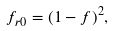<formula> <loc_0><loc_0><loc_500><loc_500>f _ { r 0 } = ( 1 - f ) ^ { 2 } ,</formula> 